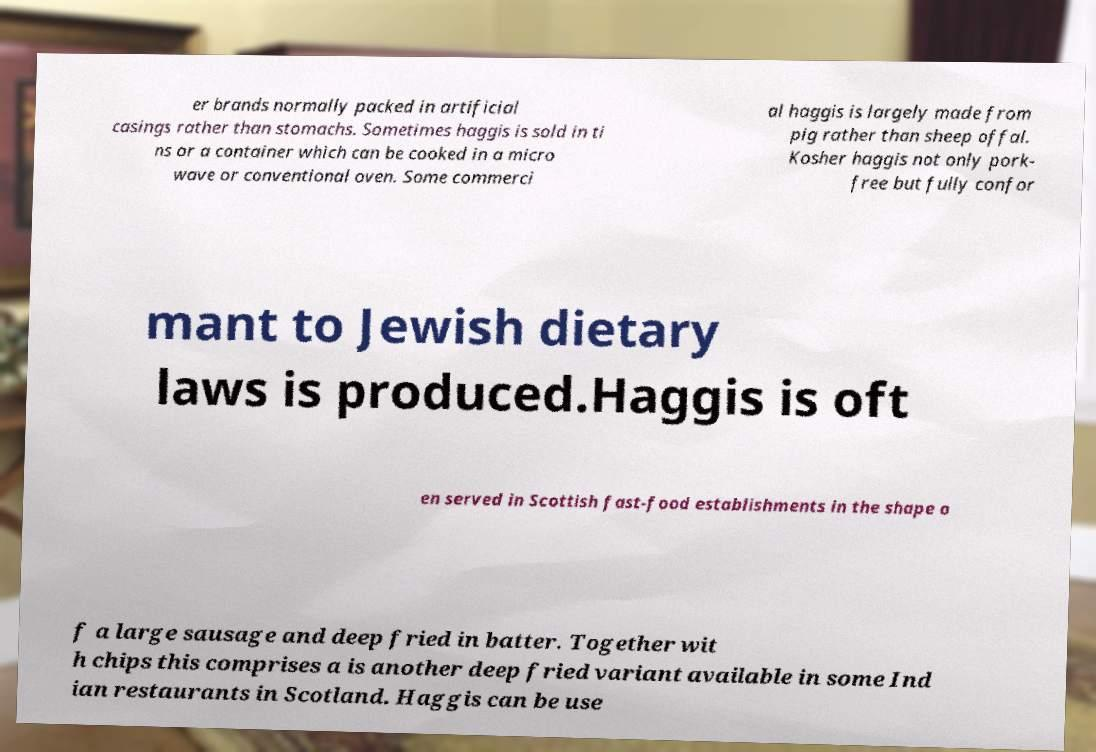What messages or text are displayed in this image? I need them in a readable, typed format. er brands normally packed in artificial casings rather than stomachs. Sometimes haggis is sold in ti ns or a container which can be cooked in a micro wave or conventional oven. Some commerci al haggis is largely made from pig rather than sheep offal. Kosher haggis not only pork- free but fully confor mant to Jewish dietary laws is produced.Haggis is oft en served in Scottish fast-food establishments in the shape o f a large sausage and deep fried in batter. Together wit h chips this comprises a is another deep fried variant available in some Ind ian restaurants in Scotland. Haggis can be use 